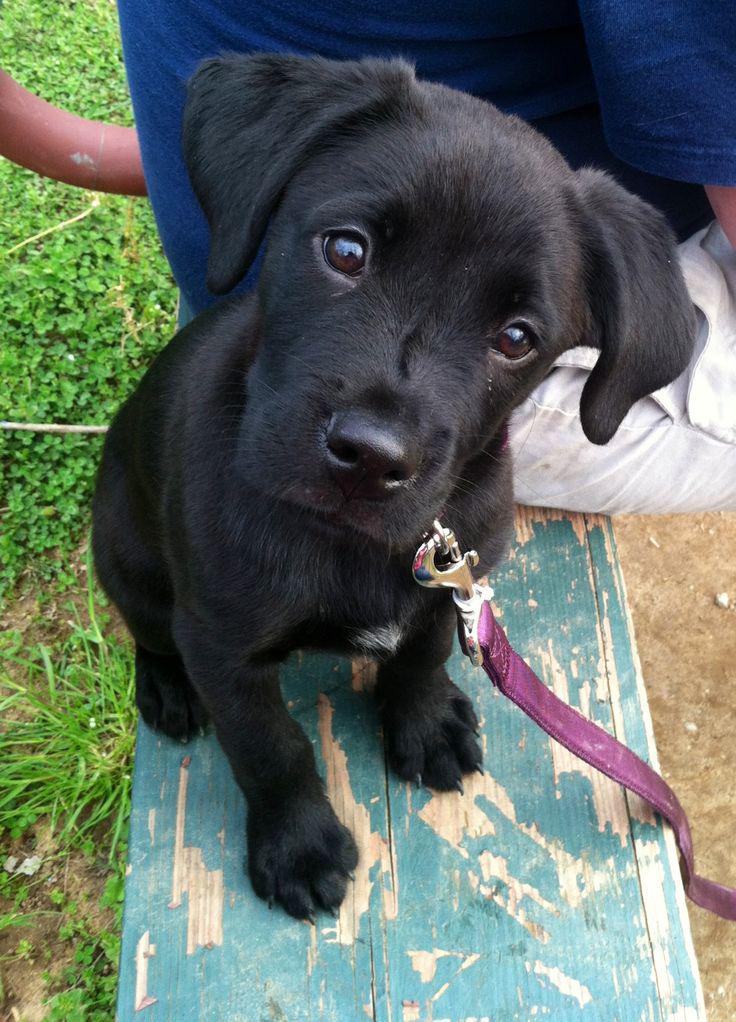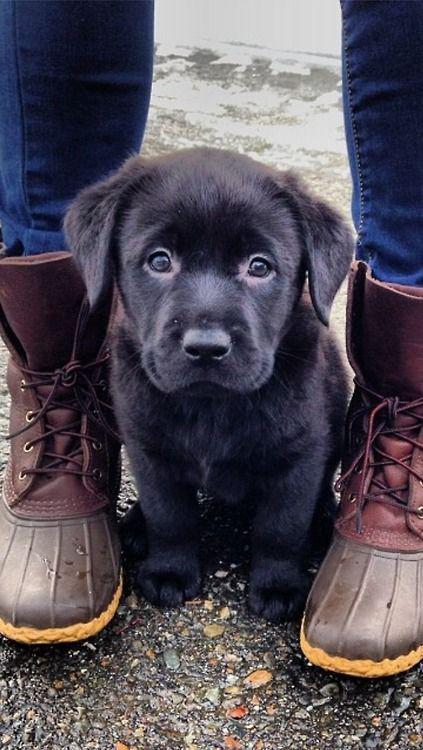The first image is the image on the left, the second image is the image on the right. Analyze the images presented: Is the assertion "Each image shows a black lab pup in a sitting pose." valid? Answer yes or no. Yes. The first image is the image on the left, the second image is the image on the right. Assess this claim about the two images: "there is a puppy with tags on it's collar". Correct or not? Answer yes or no. No. 